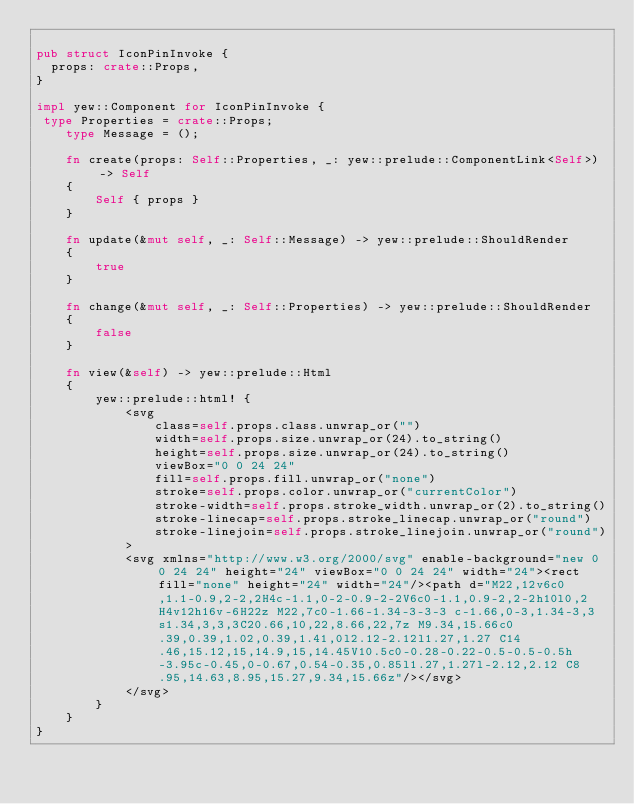Convert code to text. <code><loc_0><loc_0><loc_500><loc_500><_Rust_>
pub struct IconPinInvoke {
  props: crate::Props,
}

impl yew::Component for IconPinInvoke {
 type Properties = crate::Props;
    type Message = ();

    fn create(props: Self::Properties, _: yew::prelude::ComponentLink<Self>) -> Self
    {
        Self { props }
    }

    fn update(&mut self, _: Self::Message) -> yew::prelude::ShouldRender
    {
        true
    }

    fn change(&mut self, _: Self::Properties) -> yew::prelude::ShouldRender
    {
        false
    }

    fn view(&self) -> yew::prelude::Html
    {
        yew::prelude::html! {
            <svg
                class=self.props.class.unwrap_or("")
                width=self.props.size.unwrap_or(24).to_string()
                height=self.props.size.unwrap_or(24).to_string()
                viewBox="0 0 24 24"
                fill=self.props.fill.unwrap_or("none")
                stroke=self.props.color.unwrap_or("currentColor")
                stroke-width=self.props.stroke_width.unwrap_or(2).to_string()
                stroke-linecap=self.props.stroke_linecap.unwrap_or("round")
                stroke-linejoin=self.props.stroke_linejoin.unwrap_or("round")
            >
            <svg xmlns="http://www.w3.org/2000/svg" enable-background="new 0 0 24 24" height="24" viewBox="0 0 24 24" width="24"><rect fill="none" height="24" width="24"/><path d="M22,12v6c0,1.1-0.9,2-2,2H4c-1.1,0-2-0.9-2-2V6c0-1.1,0.9-2,2-2h10l0,2H4v12h16v-6H22z M22,7c0-1.66-1.34-3-3-3 c-1.66,0-3,1.34-3,3s1.34,3,3,3C20.66,10,22,8.66,22,7z M9.34,15.66c0.39,0.39,1.02,0.39,1.41,0l2.12-2.12l1.27,1.27 C14.46,15.12,15,14.9,15,14.45V10.5c0-0.28-0.22-0.5-0.5-0.5h-3.95c-0.45,0-0.67,0.54-0.35,0.85l1.27,1.27l-2.12,2.12 C8.95,14.63,8.95,15.27,9.34,15.66z"/></svg>
            </svg>
        }
    }
}


</code> 